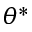Convert formula to latex. <formula><loc_0><loc_0><loc_500><loc_500>\theta ^ { * }</formula> 